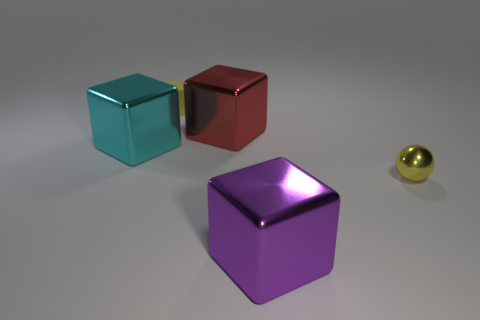Add 1 large cyan cylinders. How many objects exist? 6 Subtract all cubes. How many objects are left? 2 Add 3 large red metal blocks. How many large red metal blocks exist? 4 Subtract 1 yellow spheres. How many objects are left? 4 Subtract all red shiny cubes. Subtract all red metallic objects. How many objects are left? 3 Add 1 yellow shiny balls. How many yellow shiny balls are left? 2 